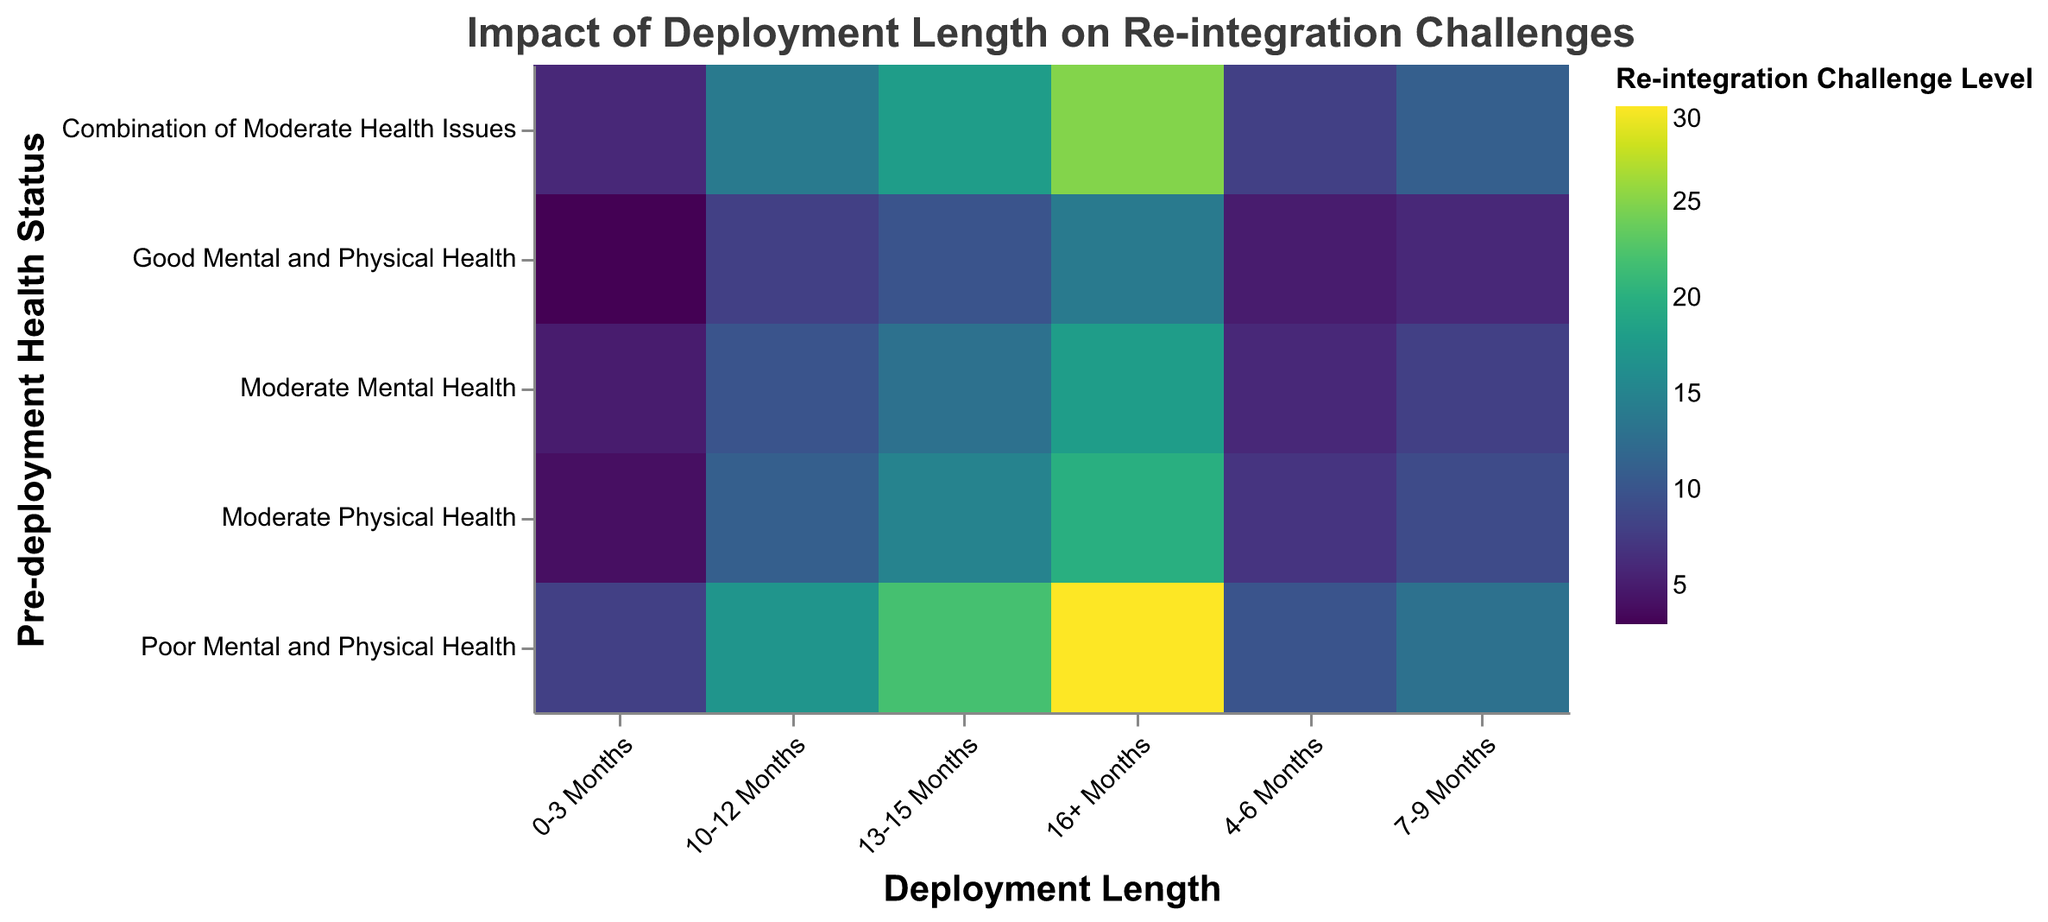What's the highest level of re-integration challenges faced by service members with good mental and physical health? Look at the row labeled "Good Mental and Physical Health" and identify the highest value, which is 14 under the "16+ Months" column.
Answer: 14 Which pre-deployment health status group experiences the highest re-integration challenges for deployments longer than 16 months? Look at the values under the "16+ Months" column and identify the highest value, which is 30 in the row "Poor Mental and Physical Health."
Answer: Poor Mental and Physical Health What is the sum of re-integration challenge levels for the group with moderate mental health across all deployment lengths? Add up the values in the "Moderate Mental Health" row: 5 + 6 + 8 + 10 + 13 + 18 = 60.
Answer: 60 Which group has a higher re-integration challenge level for deployments lasting 7-9 months: those with poor mental and physical health or those with moderate physical health? Compare the values in the "7-9 Months" column for both groups: 13 (Poor Mental and Physical Health) vs. 9 (Moderate Physical Health).
Answer: Poor Mental and Physical Health What is the average re-integration challenge level for service members with a combination of moderate health issues for the deployment lengths 0-3, 4-6, and 7-9 months? Calculate the average of the values in the "Combination of Moderate Health Issues" row for the specified columns: (6 + 8 + 11) / 3 = 8.33.
Answer: 8.33 Which deployment length is associated with the highest re-integration challenge level for service members with moderate physical health? Look at the values in the "Moderate Physical Health" row and identify the highest value, which is 20 under the "16+ Months" column.
Answer: 16+ Months How do re-integration challenge levels change as deployment length increases for service members with poor mental and physical health? Observe the trend in the "Poor Mental and Physical Health" row: values increase consistently as deployment length increases (8, 10, 13, 17, 22, 30).
Answer: Increase consistently Which pre-deployment health status groups experience higher re-integration challenges for deployments lasting 10-12 months compared to those lasting 0-3 months? Compare the values in the "10-12 Months" and "0-3 Months" columns for each group and note those that increase: Moderate Mental Health (10 > 5), Moderate Physical Health (11 > 4), Poor Mental and Physical Health (17 > 8), Combination of Moderate Health Issues (14 > 6).
Answer: Moderate Mental Health, Moderate Physical Health, Poor Mental and Physical Health, Combination of Moderate Health Issues 